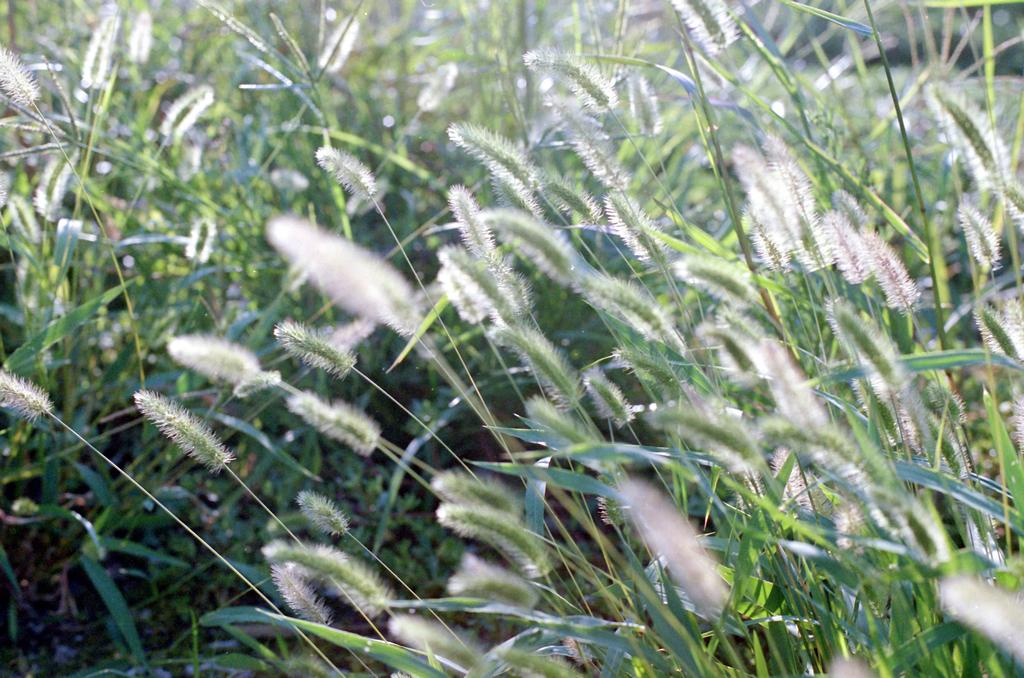What type of living organisms can be seen in the image? Plants can be seen in the image. What colors are present on the plants in the image? The plants have white and green color things on them. What type of connection can be seen between the plants in the image? There is no specific connection between the plants in the image; they are simply depicted as individual plants. 